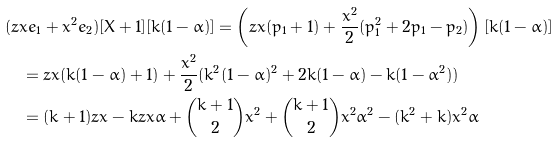Convert formula to latex. <formula><loc_0><loc_0><loc_500><loc_500>& ( z x e _ { 1 } + x ^ { 2 } e _ { 2 } ) [ X + 1 ] [ k ( 1 - \alpha ) ] = \left ( z x ( p _ { 1 } + 1 ) + \frac { x ^ { 2 } } { 2 } ( p _ { 1 } ^ { 2 } + 2 p _ { 1 } - p _ { 2 } ) \right ) [ k ( 1 - \alpha ) ] \\ & \quad = z x ( k ( 1 - \alpha ) + 1 ) + \frac { x ^ { 2 } } { 2 } ( k ^ { 2 } ( 1 - \alpha ) ^ { 2 } + 2 k ( 1 - \alpha ) - k ( 1 - \alpha ^ { 2 } ) ) \\ & \quad = ( k + 1 ) z x - k z x \alpha + { k + 1 \choose 2 } x ^ { 2 } + { k + 1 \choose 2 } x ^ { 2 } \alpha ^ { 2 } - ( k ^ { 2 } + k ) x ^ { 2 } \alpha</formula> 